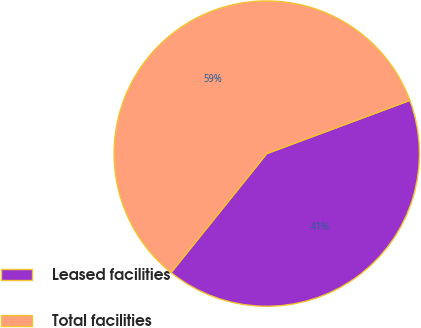Convert chart. <chart><loc_0><loc_0><loc_500><loc_500><pie_chart><fcel>Leased facilities<fcel>Total facilities<nl><fcel>41.45%<fcel>58.55%<nl></chart> 